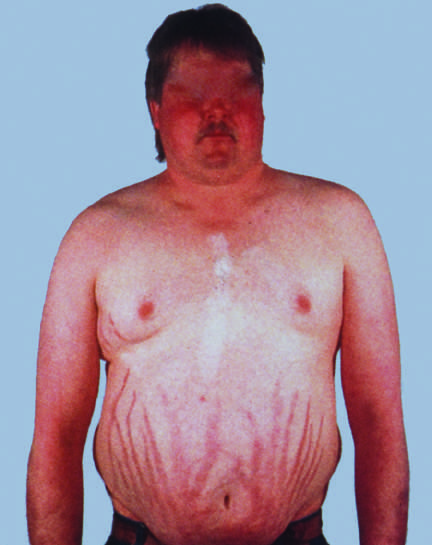what include central obesity, moon facies, and abdominal striae?
Answer the question using a single word or phrase. Characteristic features of cushing syndrome 